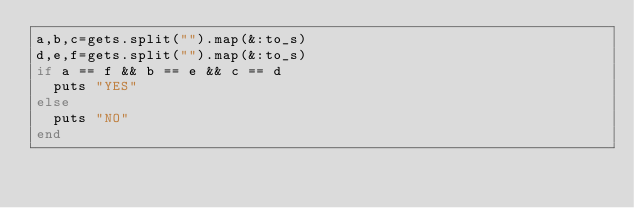Convert code to text. <code><loc_0><loc_0><loc_500><loc_500><_Ruby_>a,b,c=gets.split("").map(&:to_s)
d,e,f=gets.split("").map(&:to_s)
if a == f && b == e && c == d
  puts "YES"
else
  puts "NO"
end</code> 